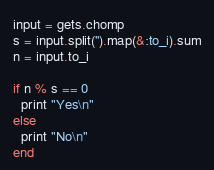Convert code to text. <code><loc_0><loc_0><loc_500><loc_500><_Ruby_>input = gets.chomp
s = input.split('').map(&:to_i).sum
n = input.to_i

if n % s == 0
  print "Yes\n"
else
  print "No\n"
end
</code> 